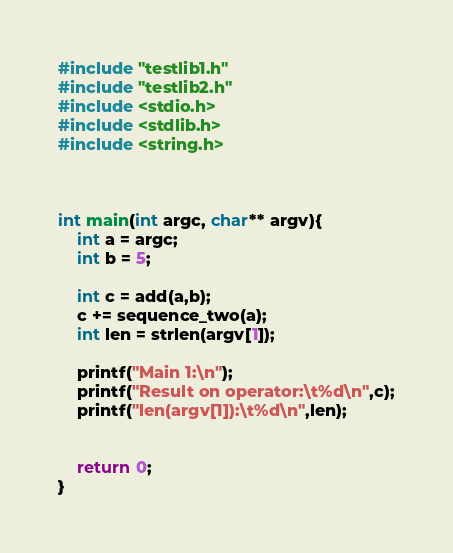Convert code to text. <code><loc_0><loc_0><loc_500><loc_500><_C_>#include "testlib1.h"
#include "testlib2.h"
#include <stdio.h>
#include <stdlib.h>
#include <string.h>



int main(int argc, char** argv){
    int a = argc;
    int b = 5;

    int c = add(a,b);
    c += sequence_two(a);
    int len = strlen(argv[1]);

    printf("Main 1:\n");
    printf("Result on operator:\t%d\n",c);
    printf("len(argv[1]):\t%d\n",len);


    return 0;
}
</code> 